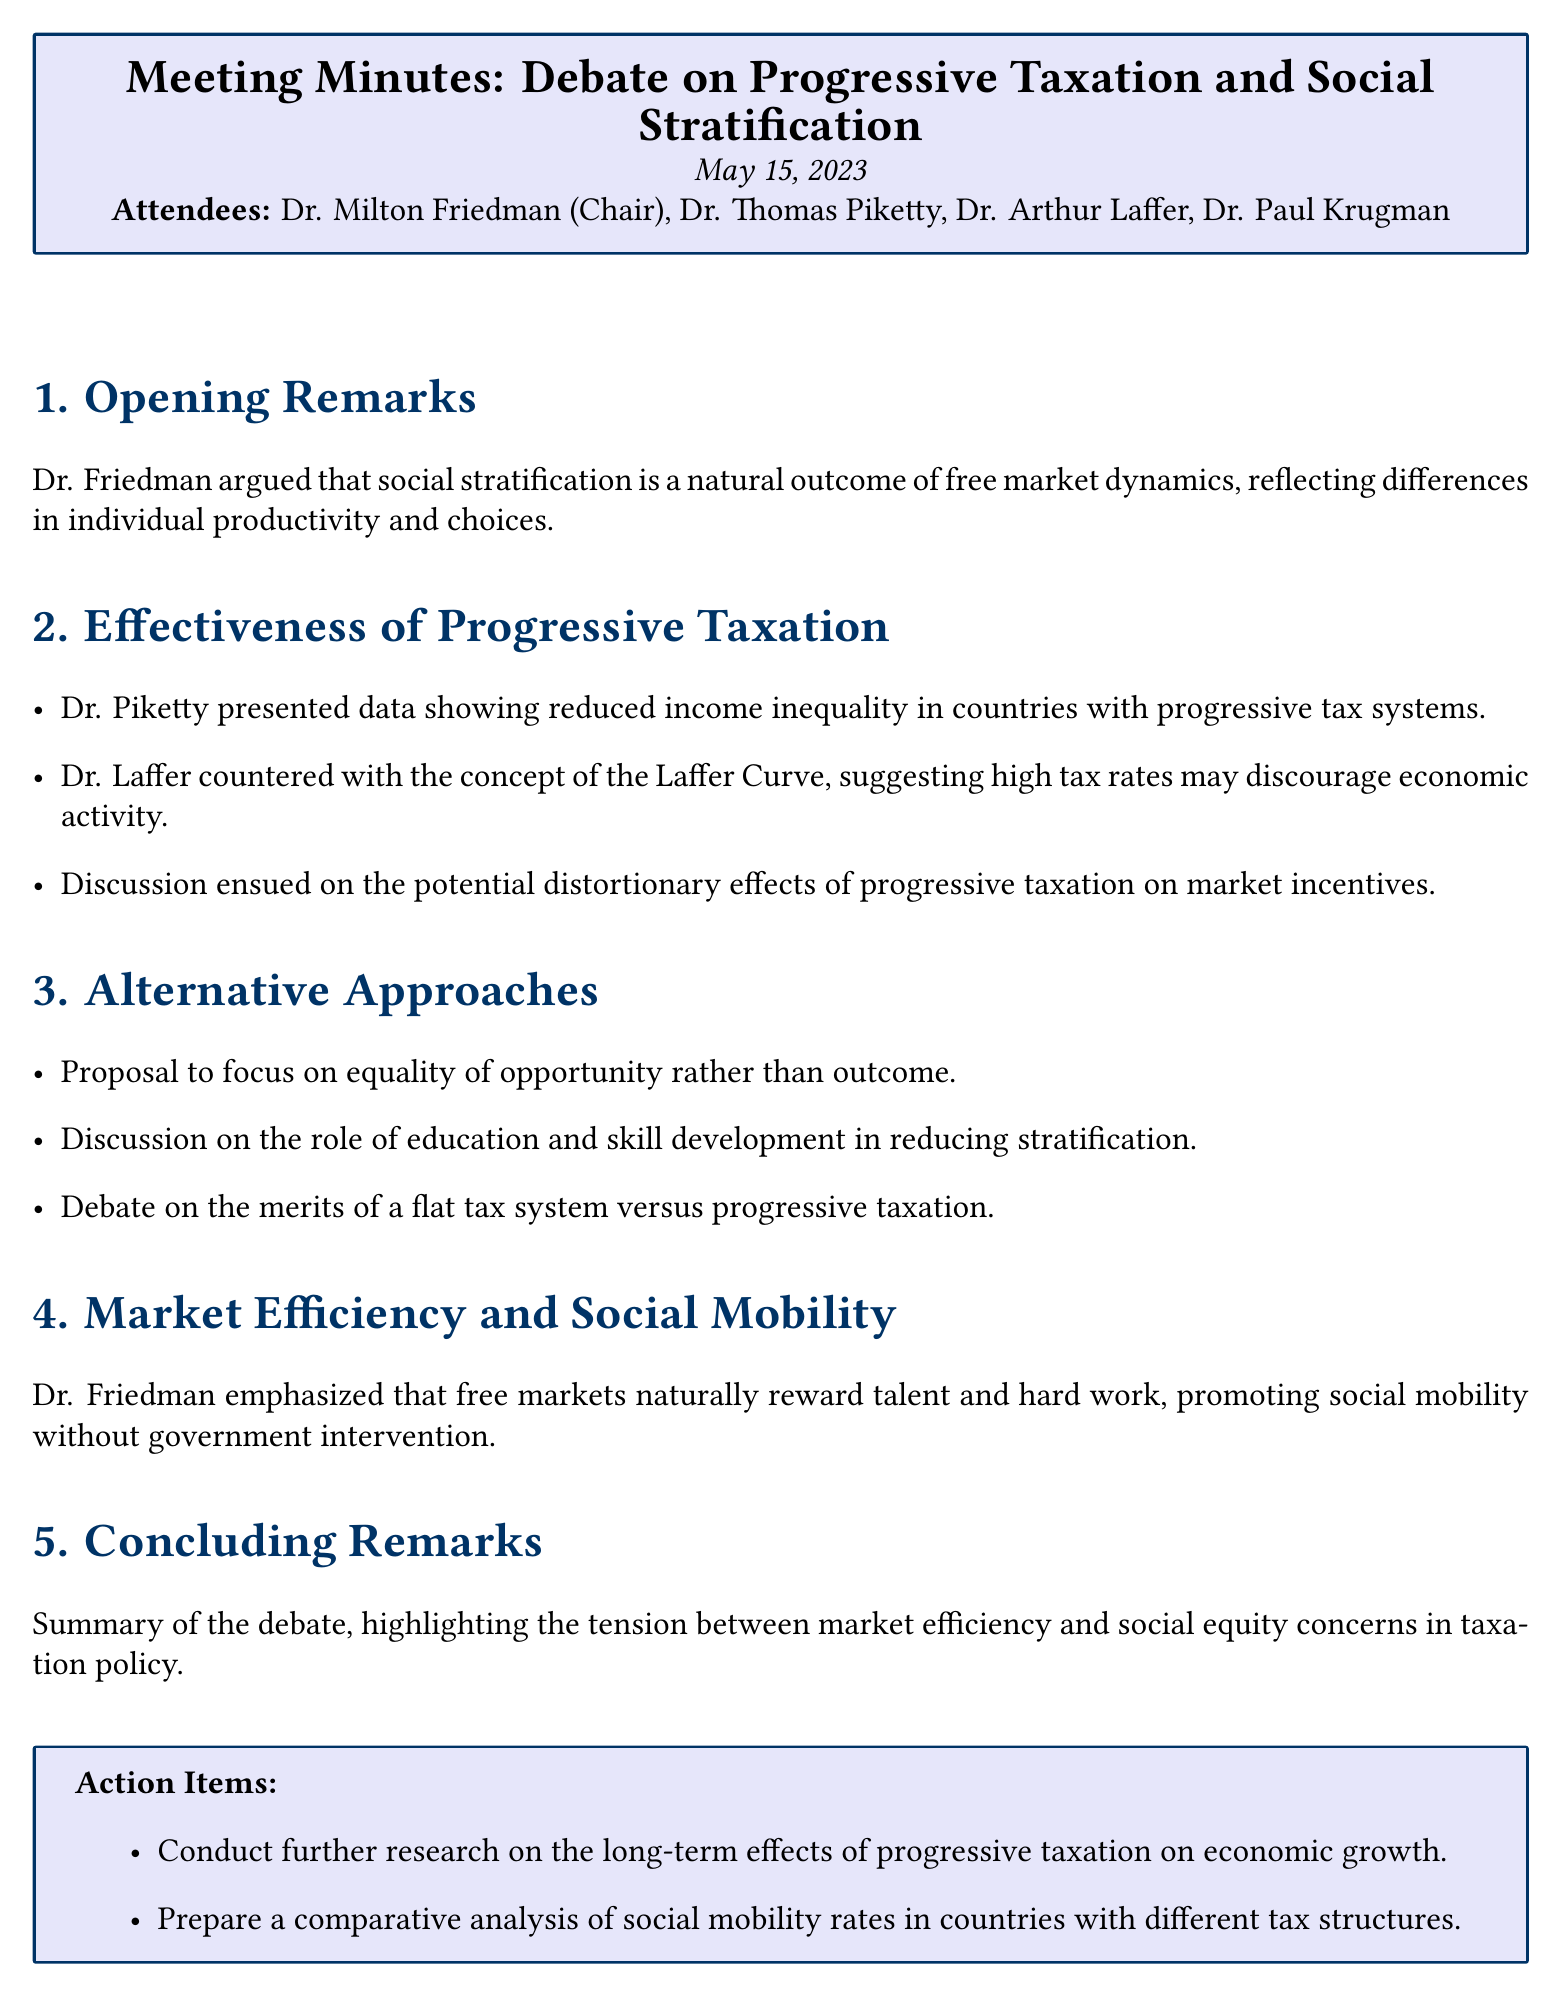What is the meeting title? The meeting title is listed at the beginning of the document.
Answer: Debate on Progressive Taxation and Social Stratification Who chaired the meeting? The chair of the meeting is mentioned in the attendee list.
Answer: Dr. Milton Friedman What date was the meeting held? The date of the meeting is stated at the top of the document.
Answer: May 15, 2023 Which doctor presented data showing reduced income inequality? The document specifies which attendee presented the data.
Answer: Dr. Thomas Piketty What concept did Dr. Laffer discuss? The document mentions a specific economic concept brought up during the meeting.
Answer: Laffer Curve What was proposed as an alternative approach? The document includes a proposal discussed during the meeting.
Answer: Equality of opportunity What is one of the action items listed? The action items are outlined at the end of the document.
Answer: Conduct further research on the long-term effects of progressive taxation on economic growth What is mentioned as a focus in discussions on reducing stratification? The document notes specific subjects discussed regarding stratification.
Answer: Education and skill development What was emphasized by Dr. Friedman regarding free markets? The document captures a key point made by Dr. Friedman about the impact of free markets.
Answer: Reward talent and hard work What type of tax system was debated besides progressive taxation? The document mentions a specific alternative tax system that was part of the discussion.
Answer: Flat tax system 